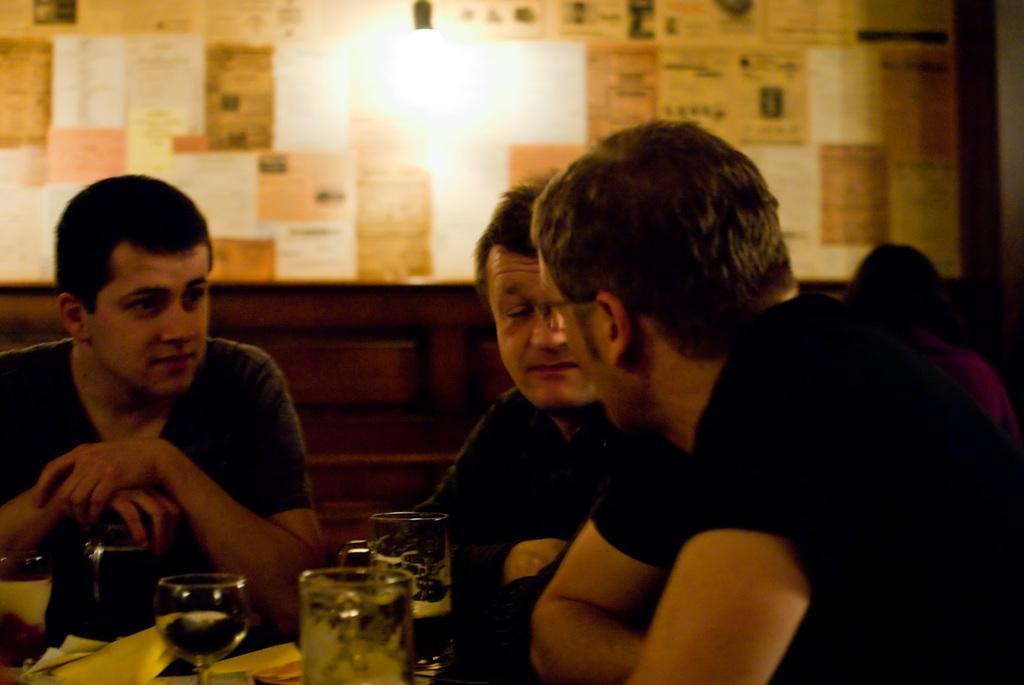How would you summarize this image in a sentence or two? There are three men sitting and wearing a black color t shirts as we can see in the middle of this image we can see glasses at the bottom of this image. There is a wall in the background. 